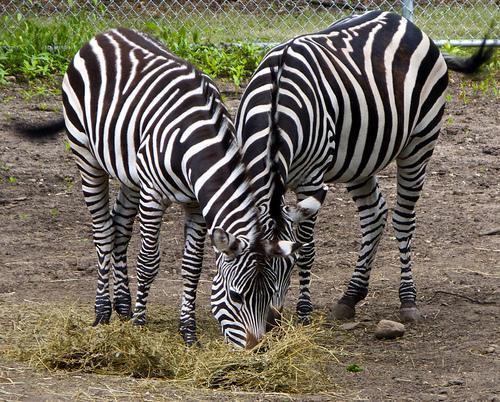How many zebras eating?
Give a very brief answer. 2. 